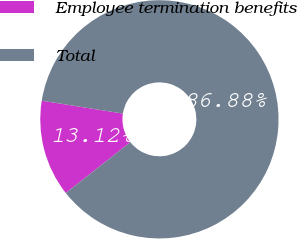<chart> <loc_0><loc_0><loc_500><loc_500><pie_chart><fcel>Employee termination benefits<fcel>Total<nl><fcel>13.12%<fcel>86.88%<nl></chart> 